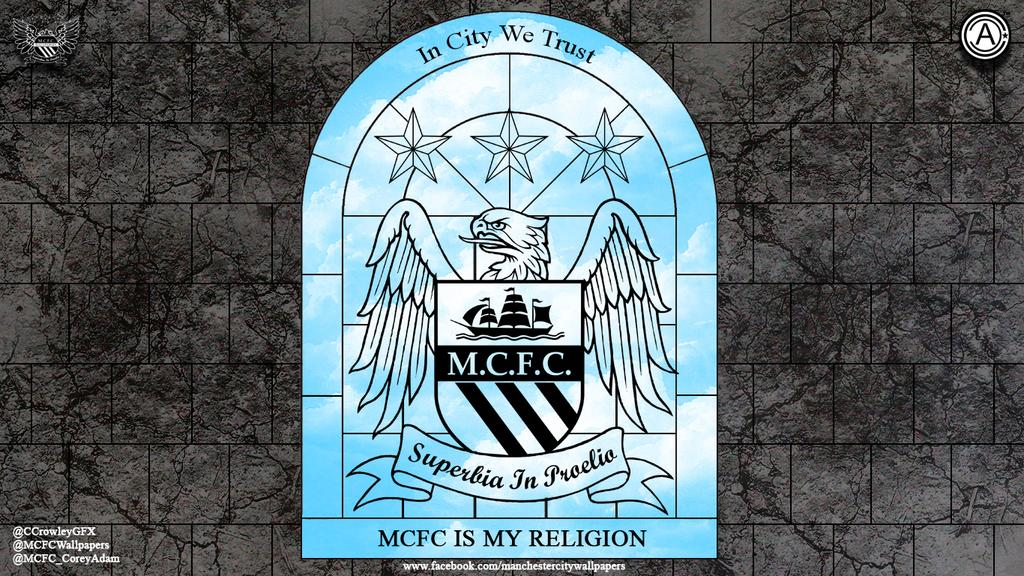Provide a one-sentence caption for the provided image. a window in a room that says MCFC is my religion. 